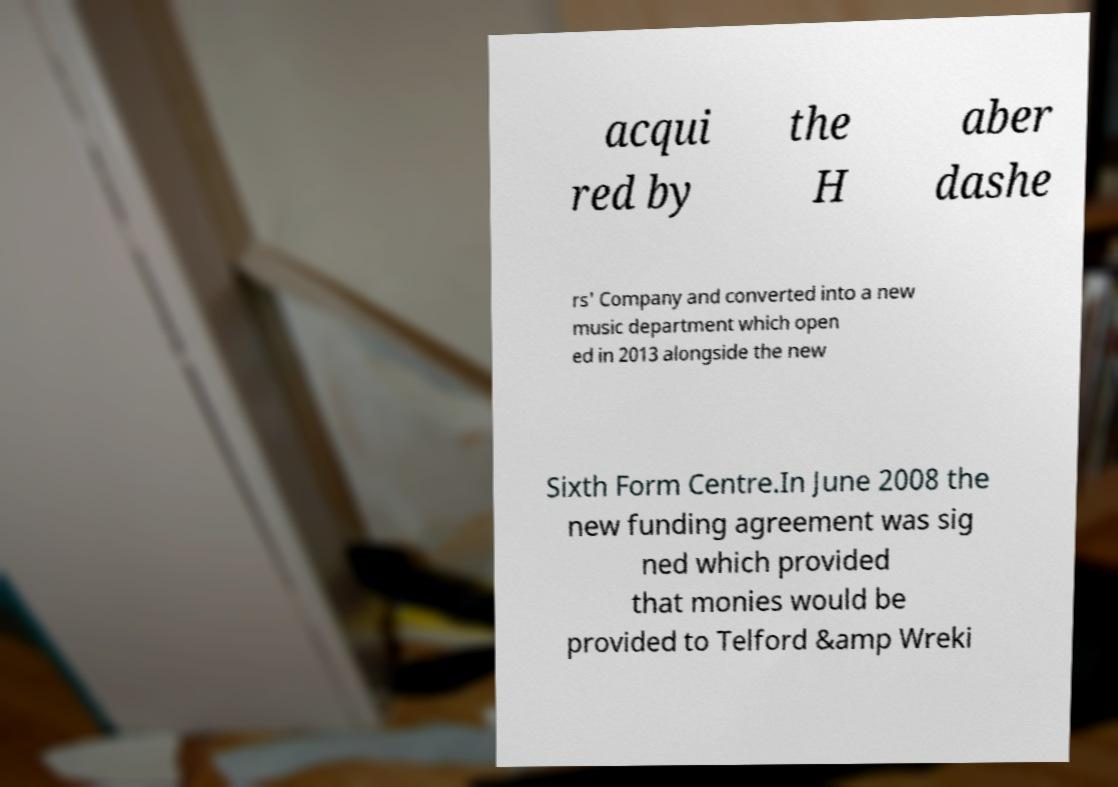Could you assist in decoding the text presented in this image and type it out clearly? acqui red by the H aber dashe rs' Company and converted into a new music department which open ed in 2013 alongside the new Sixth Form Centre.In June 2008 the new funding agreement was sig ned which provided that monies would be provided to Telford &amp Wreki 